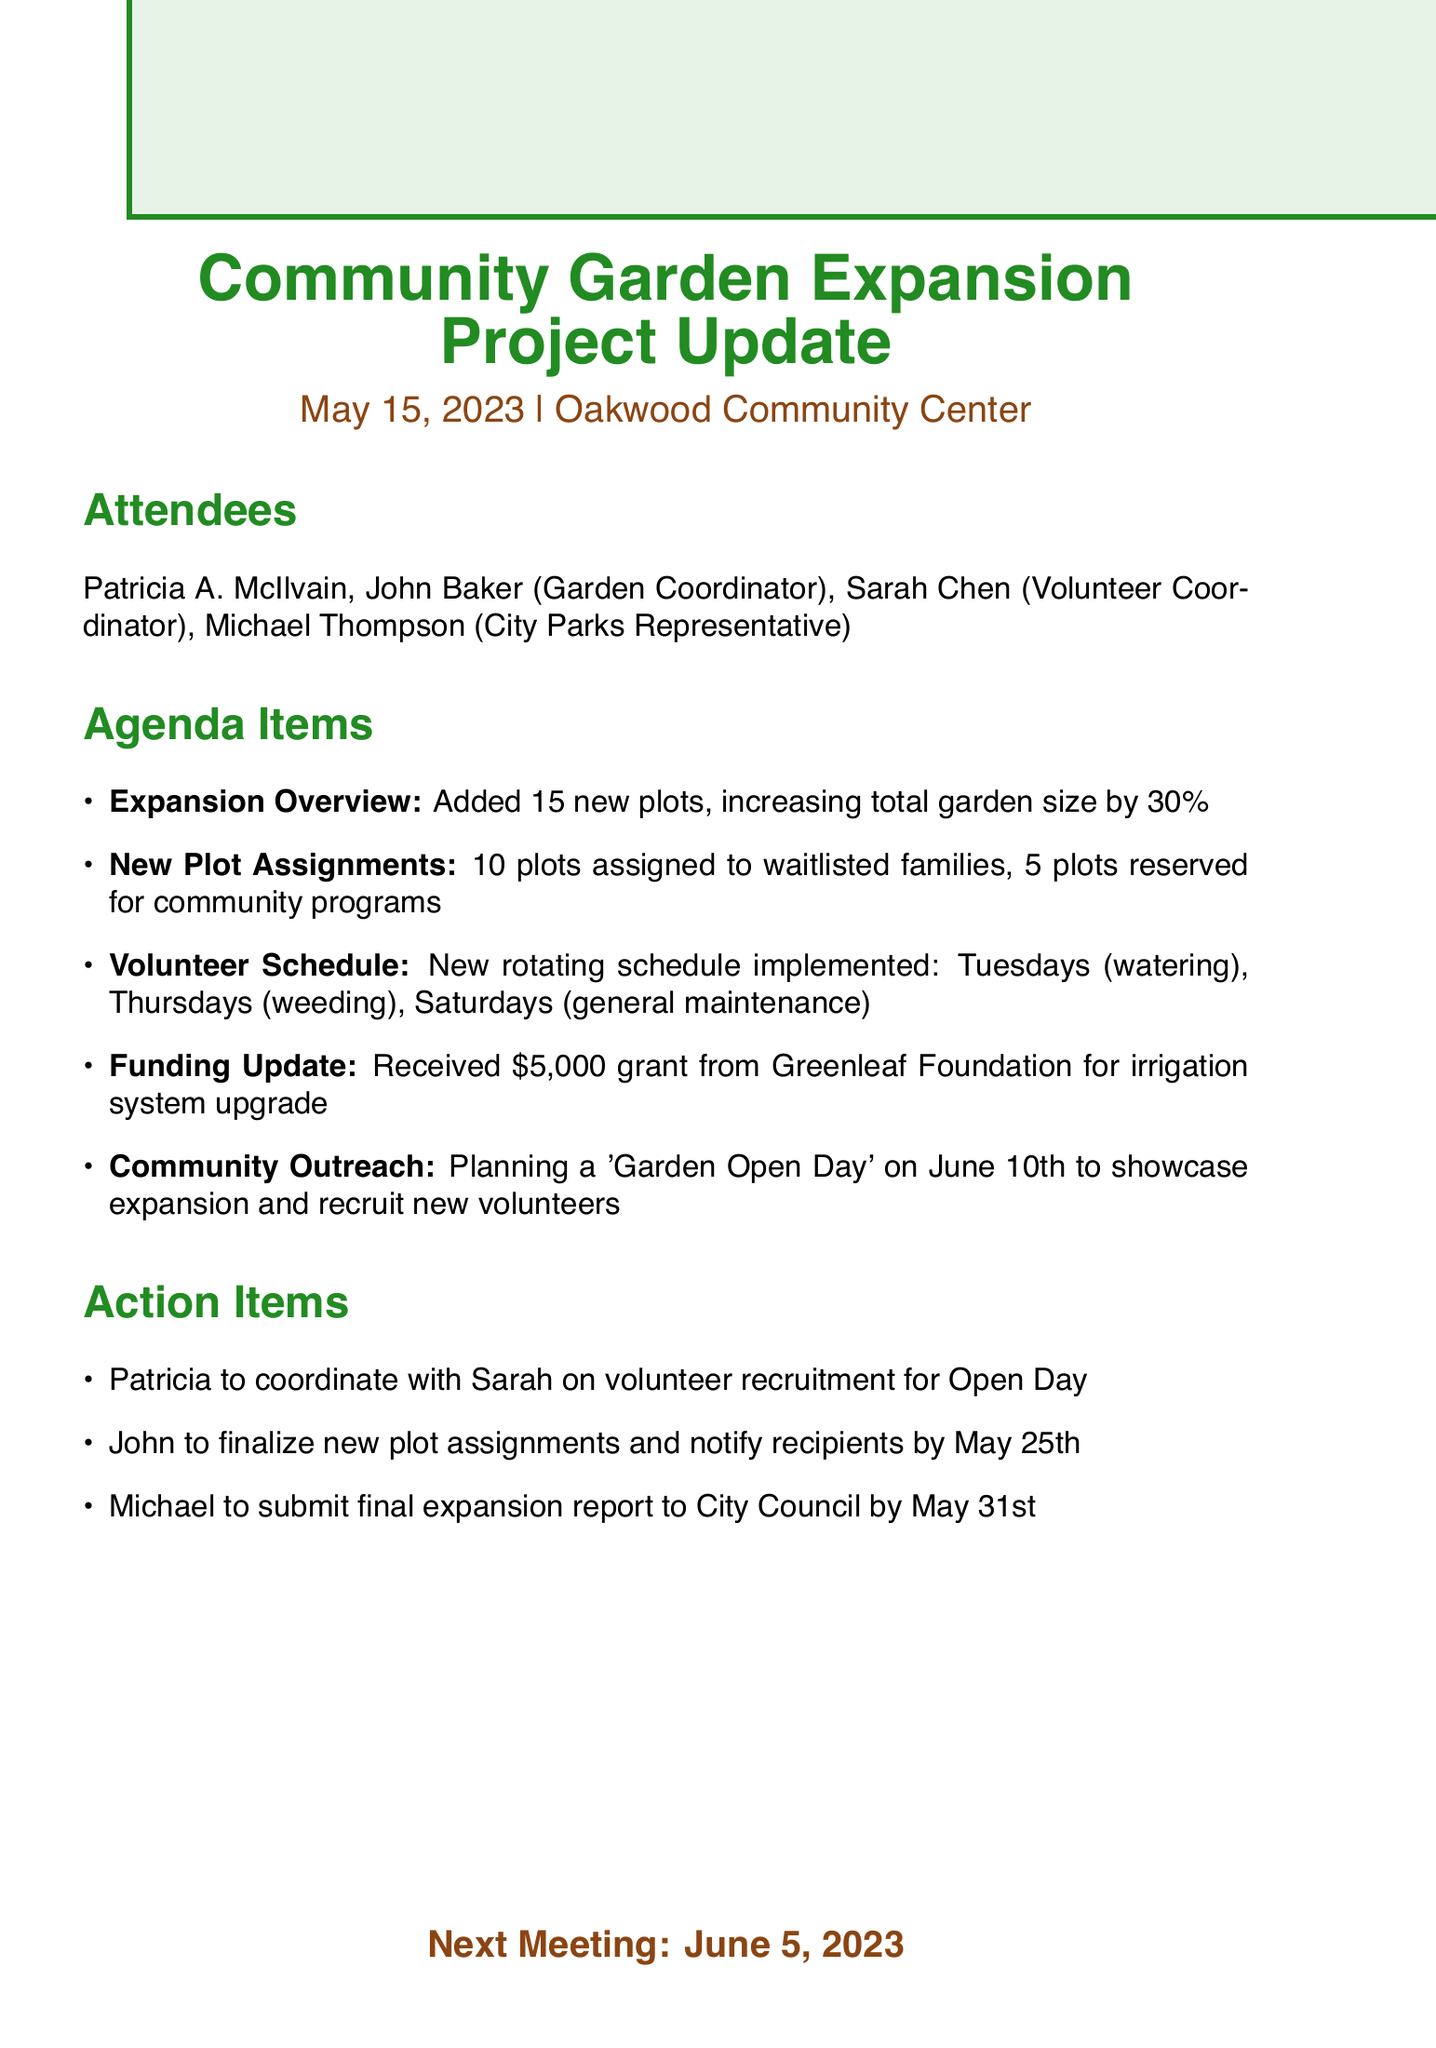What is the title of the meeting? The title of the meeting is the main heading of the document, indicating the subject matter discussed.
Answer: Community Garden Expansion Project Update What date was the meeting held? The date of the meeting is mentioned right after the title, indicating when the gathering took place.
Answer: May 15, 2023 How many new plots were added? The number of new plots is specified in the agenda item discussing the expansion overview.
Answer: 15 How many plots were assigned to waitlisted families? The number of plots assigned to waitlisted families is detailed in the new plot assignments section.
Answer: 10 What is scheduled for June 10th? The event on June 10th is mentioned as part of the community outreach plan in the agenda items.
Answer: Garden Open Day Who is responsible for notifying recipients of the new plot assignments? This responsibility is listed as an action item and indicates who will complete this task.
Answer: John When is the next meeting scheduled? The next meeting date is clearly stated at the end of the document, summarizing future gatherings.
Answer: June 5, 2023 What is the purpose of the $5,000 grant received? The purpose of the grant is explained in the funding update section of the agenda items.
Answer: Irrigation system upgrade On which days is the garden maintenance scheduled? The volunteer schedule details which tasks occur on specific days of the week.
Answer: Tuesdays, Thursdays, Saturdays 